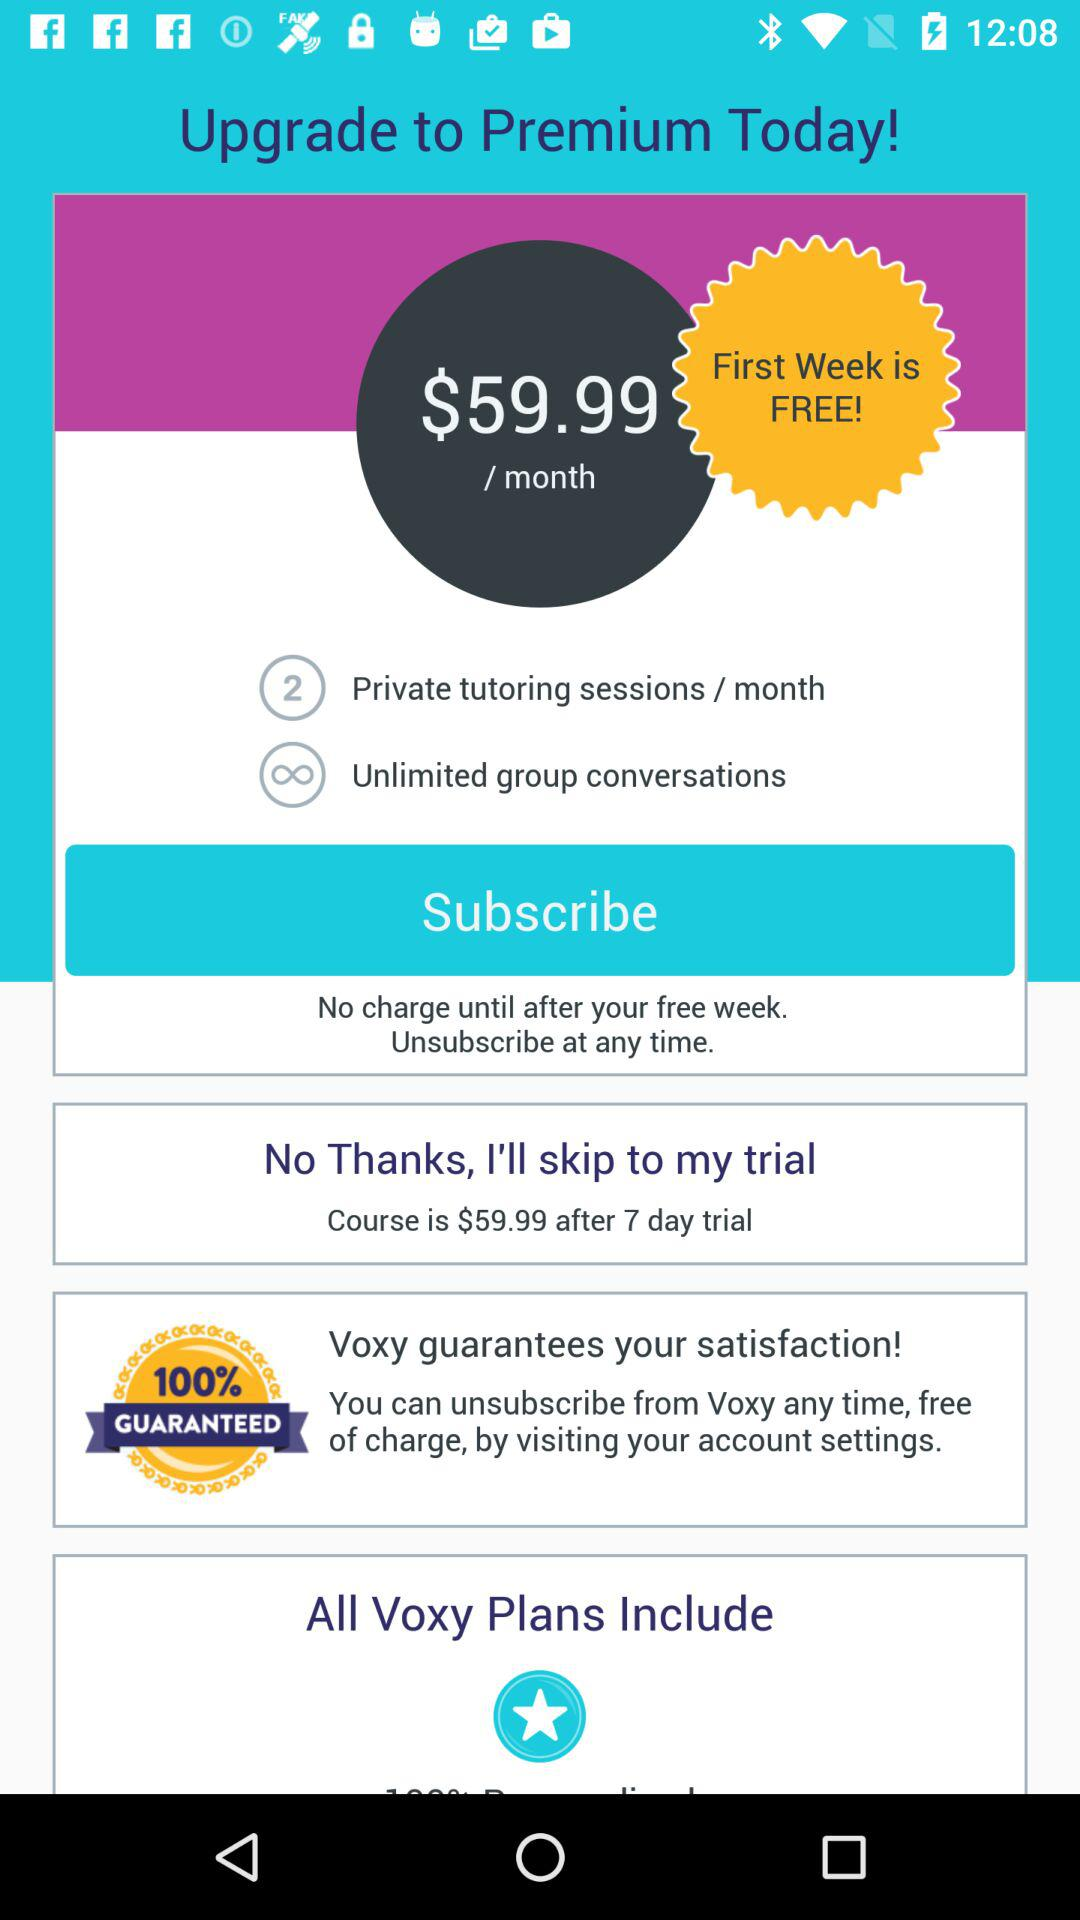What is the duration of the trial of Voxy? The duration of the trial is 7 days. 